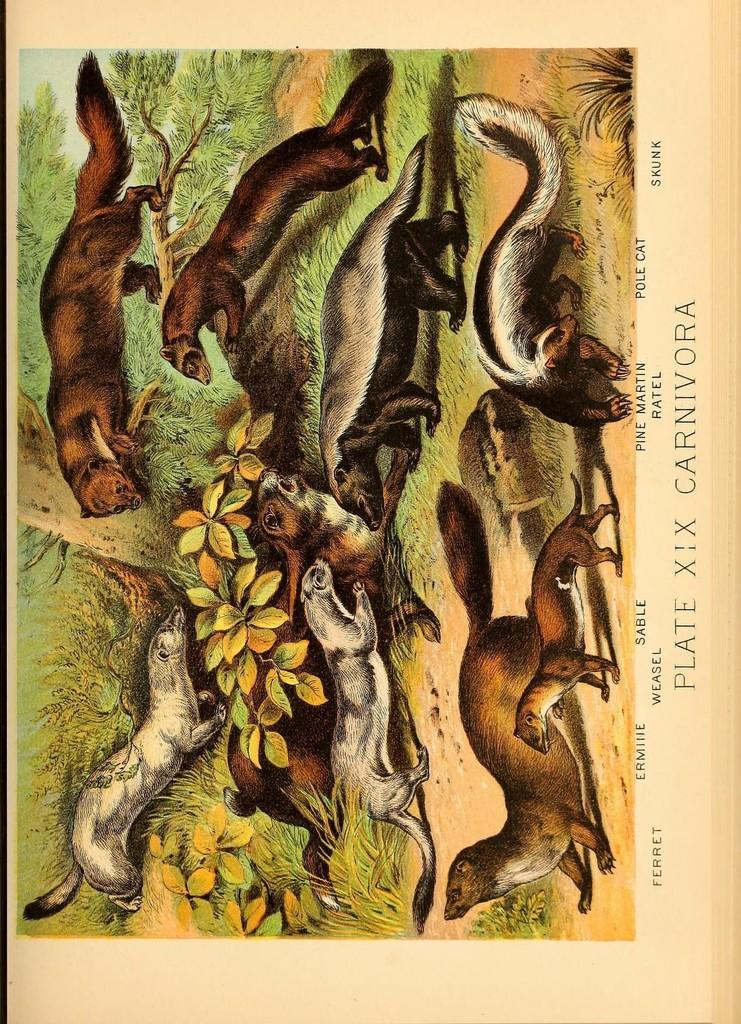What is depicted on the ground in the image? There is a picture of a group of animals on the ground. What type of natural elements can be seen in the image? Plants are visible in the image. What part of the natural environment is visible in the image? The sky is visible in the image. Is there any text present in the image? Yes, there is some text present in the image. What type of sound can be heard coming from the bucket in the image? There is no bucket present in the image, so it's not possible to determine what, if any, sound might be heard. 